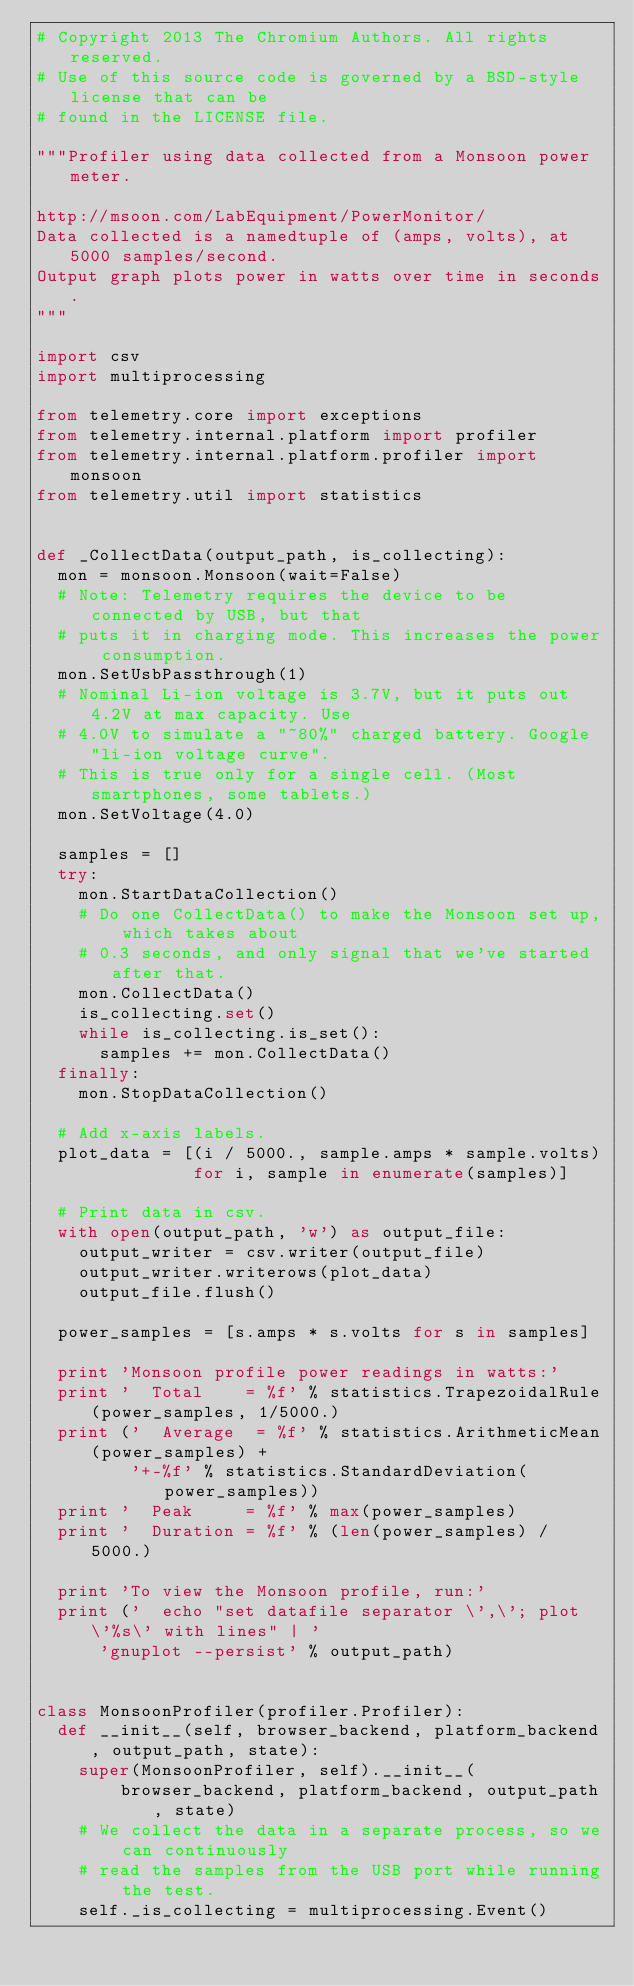<code> <loc_0><loc_0><loc_500><loc_500><_Python_># Copyright 2013 The Chromium Authors. All rights reserved.
# Use of this source code is governed by a BSD-style license that can be
# found in the LICENSE file.

"""Profiler using data collected from a Monsoon power meter.

http://msoon.com/LabEquipment/PowerMonitor/
Data collected is a namedtuple of (amps, volts), at 5000 samples/second.
Output graph plots power in watts over time in seconds.
"""

import csv
import multiprocessing

from telemetry.core import exceptions
from telemetry.internal.platform import profiler
from telemetry.internal.platform.profiler import monsoon
from telemetry.util import statistics


def _CollectData(output_path, is_collecting):
  mon = monsoon.Monsoon(wait=False)
  # Note: Telemetry requires the device to be connected by USB, but that
  # puts it in charging mode. This increases the power consumption.
  mon.SetUsbPassthrough(1)
  # Nominal Li-ion voltage is 3.7V, but it puts out 4.2V at max capacity. Use
  # 4.0V to simulate a "~80%" charged battery. Google "li-ion voltage curve".
  # This is true only for a single cell. (Most smartphones, some tablets.)
  mon.SetVoltage(4.0)

  samples = []
  try:
    mon.StartDataCollection()
    # Do one CollectData() to make the Monsoon set up, which takes about
    # 0.3 seconds, and only signal that we've started after that.
    mon.CollectData()
    is_collecting.set()
    while is_collecting.is_set():
      samples += mon.CollectData()
  finally:
    mon.StopDataCollection()

  # Add x-axis labels.
  plot_data = [(i / 5000., sample.amps * sample.volts)
               for i, sample in enumerate(samples)]

  # Print data in csv.
  with open(output_path, 'w') as output_file:
    output_writer = csv.writer(output_file)
    output_writer.writerows(plot_data)
    output_file.flush()

  power_samples = [s.amps * s.volts for s in samples]

  print 'Monsoon profile power readings in watts:'
  print '  Total    = %f' % statistics.TrapezoidalRule(power_samples, 1/5000.)
  print ('  Average  = %f' % statistics.ArithmeticMean(power_samples) +
         '+-%f' % statistics.StandardDeviation(power_samples))
  print '  Peak     = %f' % max(power_samples)
  print '  Duration = %f' % (len(power_samples) / 5000.)

  print 'To view the Monsoon profile, run:'
  print ('  echo "set datafile separator \',\'; plot \'%s\' with lines" | '
      'gnuplot --persist' % output_path)


class MonsoonProfiler(profiler.Profiler):
  def __init__(self, browser_backend, platform_backend, output_path, state):
    super(MonsoonProfiler, self).__init__(
        browser_backend, platform_backend, output_path, state)
    # We collect the data in a separate process, so we can continuously
    # read the samples from the USB port while running the test.
    self._is_collecting = multiprocessing.Event()</code> 